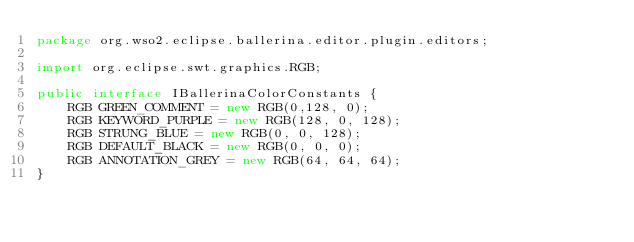<code> <loc_0><loc_0><loc_500><loc_500><_Java_>package org.wso2.eclipse.ballerina.editor.plugin.editors;

import org.eclipse.swt.graphics.RGB;

public interface IBallerinaColorConstants {
	RGB GREEN_COMMENT = new RGB(0,128, 0);
	RGB KEYWORD_PURPLE = new RGB(128, 0, 128);
	RGB STRUNG_BLUE = new RGB(0, 0, 128);
	RGB DEFAULT_BLACK = new RGB(0, 0, 0);
	RGB ANNOTATION_GREY = new RGB(64, 64, 64);
}
</code> 